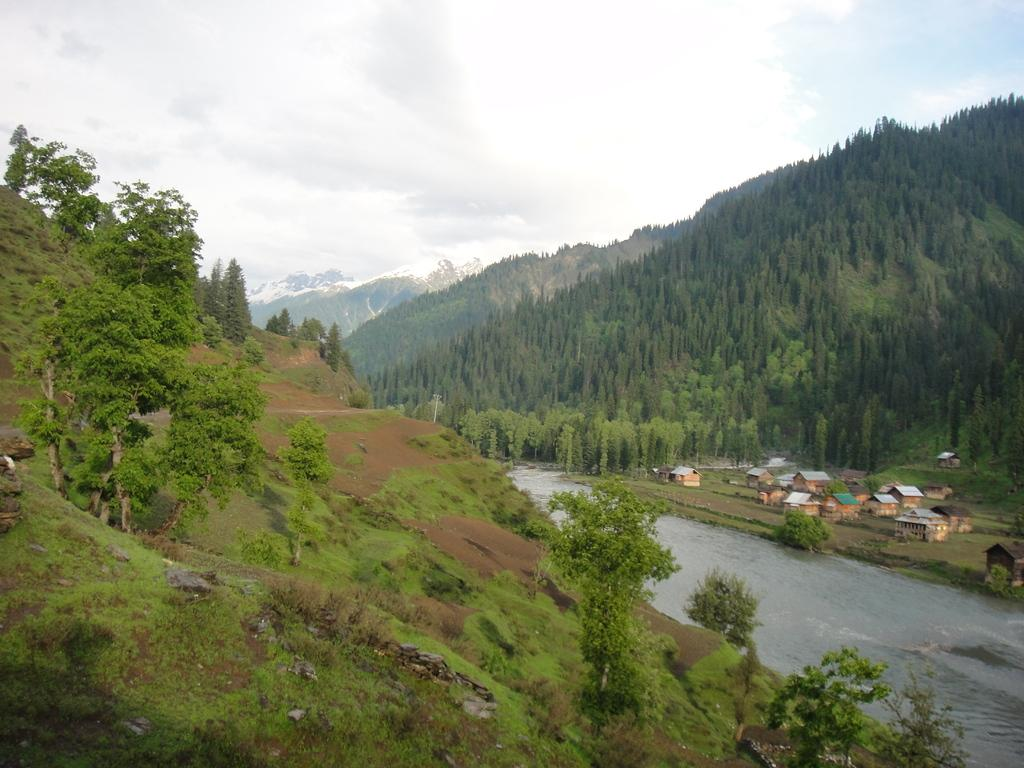What type of vegetation is present in the image? There are trees in the image. What is the color of the trees? The trees are green. What else can be seen in the image besides trees? There is water visible in the image, as well as huts. What is the color of the sky in the background? The sky is white in the background. What type of juice is being served in the huts in the image? There is no juice or indication of any beverage being served in the huts in the image. 